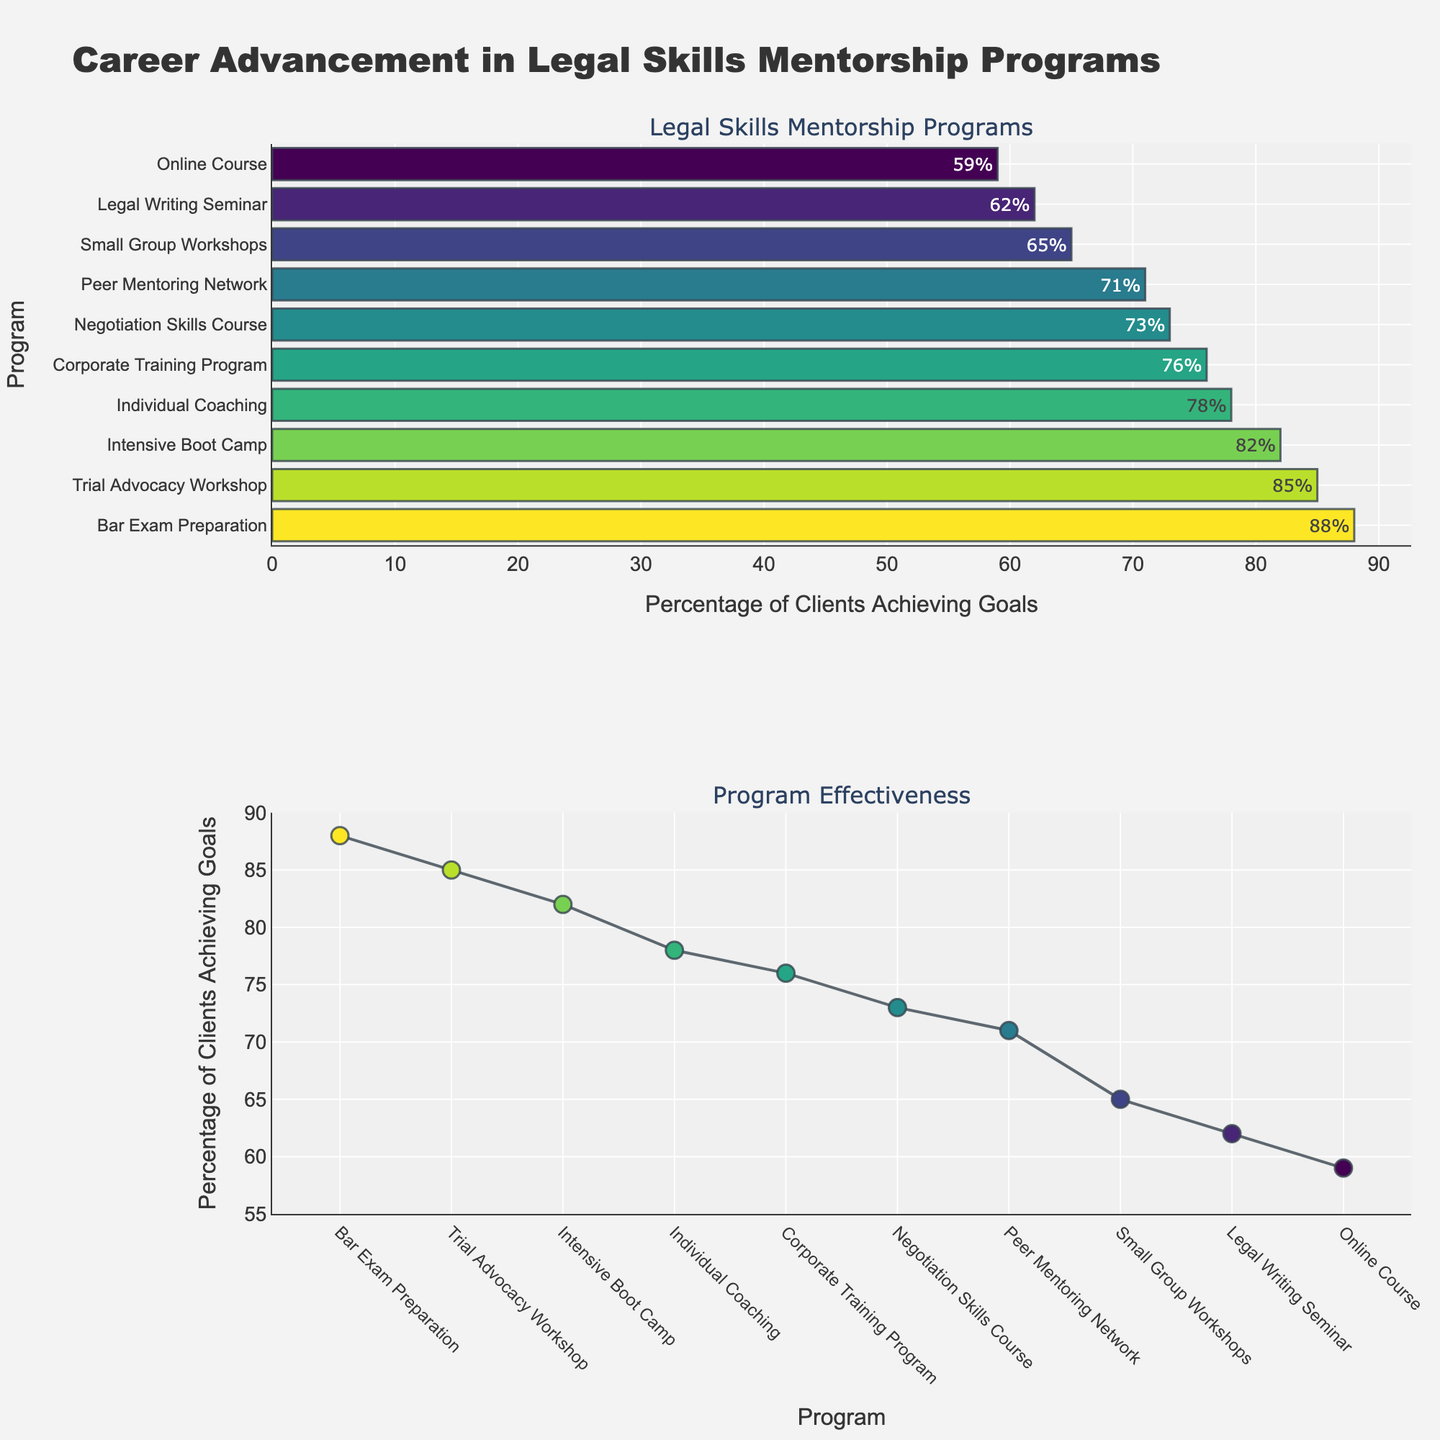Which Program has the highest percentage of clients achieving career advancement goals? The highest bar in the bar chart indicates the program with the highest percentage. From the data, the 'Bar Exam Preparation' program has the highest bar, corresponding to 88%.
Answer: Bar Exam Preparation What is the title of the figure? The title is displayed at the top of the figure. The title text is "Career Advancement in Legal Skills Mentorship Programs".
Answer: Career Advancement in Legal Skills Mentorship Programs How many programs have a percentage of 80% or higher? The figure shows bars with percentages on a horizontal axis. The bars corresponding to 'Bar Exam Preparation' (88%), 'Trial Advocacy Workshop' (85%), and 'Intensive Boot Camp' (82%) indicate 3 programs.
Answer: 3 Which program has the lowest percentage of clients achieving career advancement goals? The smallest bar in the bar chart represents the program with the lowest percentage. According to the data, the 'Online Course' program has the lowest bar at 59%.
Answer: Online Course How do the 'Individual Coaching' and 'Corporate Training Program' percentages compare? Locate the bars for both programs on the bar chart and compare the heights and the values. 'Individual Coaching' has 78%, while 'Corporate Training Program' has 76%. Consequently, Individual Coaching is slightly higher.
Answer: Individual Coaching is higher What is the difference in percentage between the 'Legal Writing Seminar' and 'Negotiation Skills Course'? Look at the values associated with each program: 'Legal Writing Seminar' is 62%, and 'Negotiation Skills Course' is 73%. Calculate the difference: 73% - 62% = 11%.
Answer: 11% What does the x-axis represent in the scatter plot? The x-axis in the scatter plot lists different programs, which is evident from the labeled ticks along the horizontal axis.
Answer: Program Which two programs have the closest percentage of clients achieving career advancement goals? Compare the values of the bars and look for the smallest difference. 'Corporate Training Program' (76%) and 'Peer Mentoring Network' (71%) have a 5% difference, and a smaller difference is the right answer. 'Individual Coaching' (78%) and 'Corporate Training Program' (76%) is a 2% difference.
Answer: Individual Coaching and Corporate Training Program Are more than half of the programs above 70% client success rate? Evaluate each bar's percentage value and count those equal to or above 70%. There are 7 programs ('Individual Coaching', 'Small Group Workshops', 'Intensive Boot Camp', 'Peer Mentoring Network', 'Corporate Training Program', 'Negotiation Skills Course', 'Trial Advocacy Workshop', and 'Bar Exam Preparation') out of 10, indicating more than half.
Answer: Yes How does the visual appearance of the bar chart help in understanding the effectiveness of different programs? The length of each bar is proportional to the percentage of client success, with color intensity also varying by percentage. It clearly shows which programs are more effective through longer and darker bars.
Answer: Longer and darker bars indicate higher effectiveness 